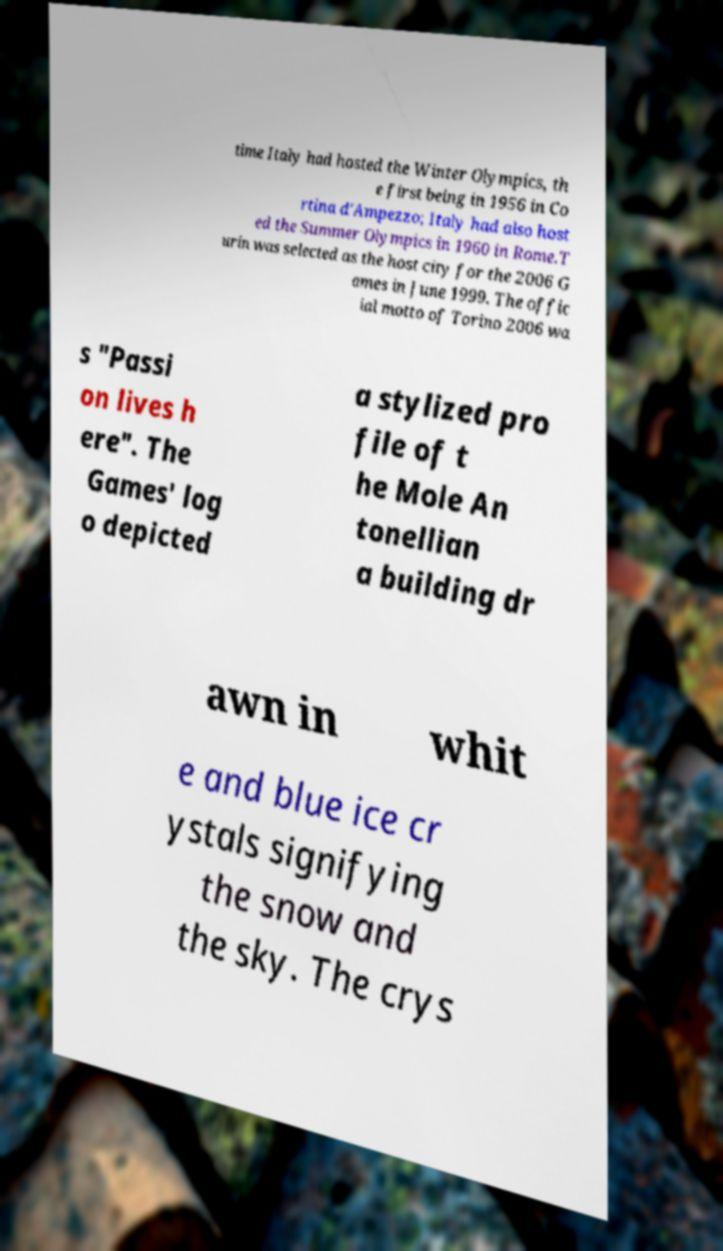Please identify and transcribe the text found in this image. time Italy had hosted the Winter Olympics, th e first being in 1956 in Co rtina d'Ampezzo; Italy had also host ed the Summer Olympics in 1960 in Rome.T urin was selected as the host city for the 2006 G ames in June 1999. The offic ial motto of Torino 2006 wa s "Passi on lives h ere". The Games' log o depicted a stylized pro file of t he Mole An tonellian a building dr awn in whit e and blue ice cr ystals signifying the snow and the sky. The crys 